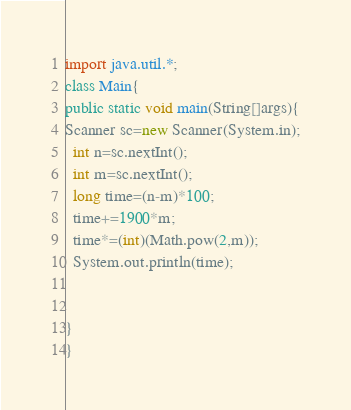Convert code to text. <code><loc_0><loc_0><loc_500><loc_500><_Java_>import java.util.*;
class Main{
public static void main(String[]args){
Scanner sc=new Scanner(System.in);
  int n=sc.nextInt();
  int m=sc.nextInt();
  long time=(n-m)*100;
  time+=1900*m;
  time*=(int)(Math.pow(2,m));
  System.out.println(time);
    

}
}
</code> 